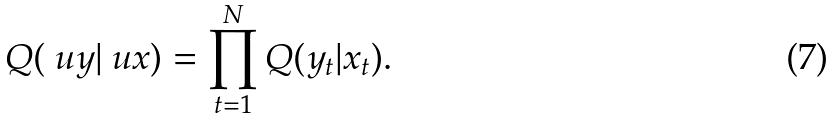Convert formula to latex. <formula><loc_0><loc_0><loc_500><loc_500>Q ( \ u y | \ u x ) & = \prod _ { t = 1 } ^ { N } Q ( y _ { t } | x _ { t } ) .</formula> 